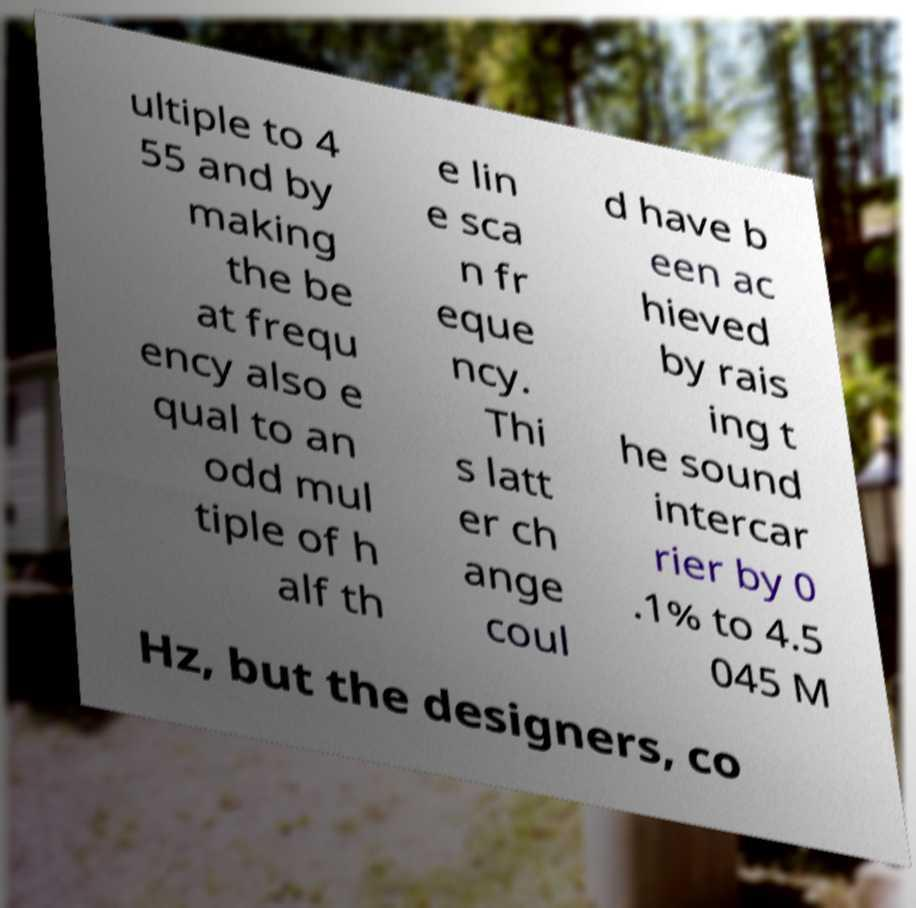For documentation purposes, I need the text within this image transcribed. Could you provide that? ultiple to 4 55 and by making the be at frequ ency also e qual to an odd mul tiple of h alf th e lin e sca n fr eque ncy. Thi s latt er ch ange coul d have b een ac hieved by rais ing t he sound intercar rier by 0 .1% to 4.5 045 M Hz, but the designers, co 